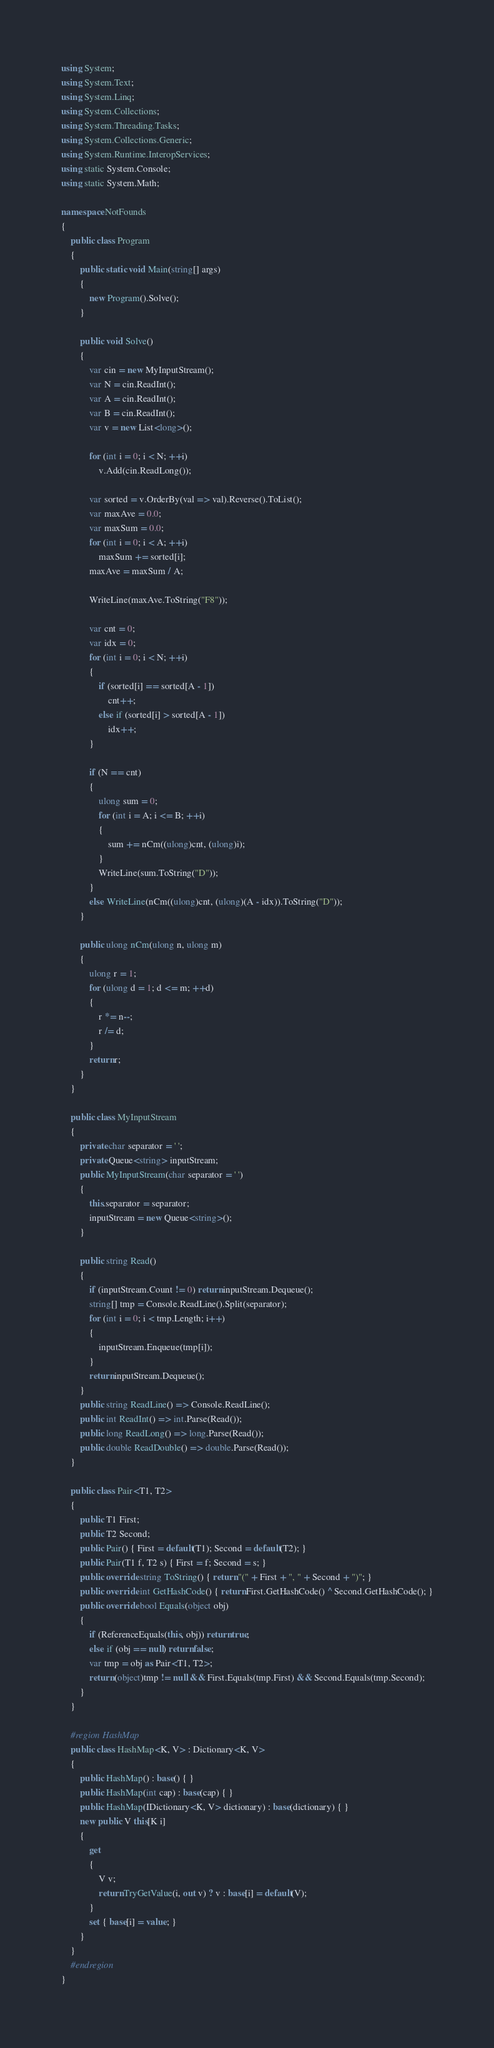<code> <loc_0><loc_0><loc_500><loc_500><_C#_>using System;
using System.Text;
using System.Linq;
using System.Collections;
using System.Threading.Tasks;
using System.Collections.Generic;
using System.Runtime.InteropServices;
using static System.Console;
using static System.Math;

namespace NotFounds
{
    public class Program
    {
        public static void Main(string[] args)
        {
            new Program().Solve();
        }

        public void Solve()
        {
            var cin = new MyInputStream();
            var N = cin.ReadInt();
            var A = cin.ReadInt();
            var B = cin.ReadInt();
            var v = new List<long>();

            for (int i = 0; i < N; ++i)
                v.Add(cin.ReadLong());

            var sorted = v.OrderBy(val => val).Reverse().ToList();
            var maxAve = 0.0;
            var maxSum = 0.0;
            for (int i = 0; i < A; ++i)
                maxSum += sorted[i];
            maxAve = maxSum / A;

            WriteLine(maxAve.ToString("F8"));

            var cnt = 0;
            var idx = 0;
            for (int i = 0; i < N; ++i)
            {
                if (sorted[i] == sorted[A - 1])
                    cnt++;
                else if (sorted[i] > sorted[A - 1])
                    idx++;
            }

            if (N == cnt)
            {
                ulong sum = 0;
                for (int i = A; i <= B; ++i)
                {
                    sum += nCm((ulong)cnt, (ulong)i);
                }
                WriteLine(sum.ToString("D"));
            }
            else WriteLine(nCm((ulong)cnt, (ulong)(A - idx)).ToString("D"));
        }

        public ulong nCm(ulong n, ulong m)
        {
            ulong r = 1;
            for (ulong d = 1; d <= m; ++d)
            {
                r *= n--;
                r /= d;
            }
            return r;
        }
    }

    public class MyInputStream
    {
        private char separator = ' ';
        private Queue<string> inputStream;
        public MyInputStream(char separator = ' ')
        {
            this.separator = separator;
            inputStream = new Queue<string>();
        }

        public string Read()
        {
            if (inputStream.Count != 0) return inputStream.Dequeue();
            string[] tmp = Console.ReadLine().Split(separator);
            for (int i = 0; i < tmp.Length; i++)
            {
                inputStream.Enqueue(tmp[i]);
            }
            return inputStream.Dequeue();
        }
        public string ReadLine() => Console.ReadLine();
        public int ReadInt() => int.Parse(Read());
        public long ReadLong() => long.Parse(Read());
        public double ReadDouble() => double.Parse(Read());
    }

    public class Pair<T1, T2>
    {
        public T1 First;
        public T2 Second;
        public Pair() { First = default(T1); Second = default(T2); }
        public Pair(T1 f, T2 s) { First = f; Second = s; }
        public override string ToString() { return "(" + First + ", " + Second + ")"; }
        public override int GetHashCode() { return First.GetHashCode() ^ Second.GetHashCode(); }
        public override bool Equals(object obj)
        {
            if (ReferenceEquals(this, obj)) return true;
            else if (obj == null) return false;
            var tmp = obj as Pair<T1, T2>;
            return (object)tmp != null && First.Equals(tmp.First) && Second.Equals(tmp.Second);
        }
    }

    #region HashMap
    public class HashMap<K, V> : Dictionary<K, V>
    {
        public HashMap() : base() { }
        public HashMap(int cap) : base(cap) { }
        public HashMap(IDictionary<K, V> dictionary) : base(dictionary) { }
        new public V this[K i]
        {
            get
            {
                V v;
                return TryGetValue(i, out v) ? v : base[i] = default(V);
            }
            set { base[i] = value; }
        }
    }
    #endregion
}
</code> 